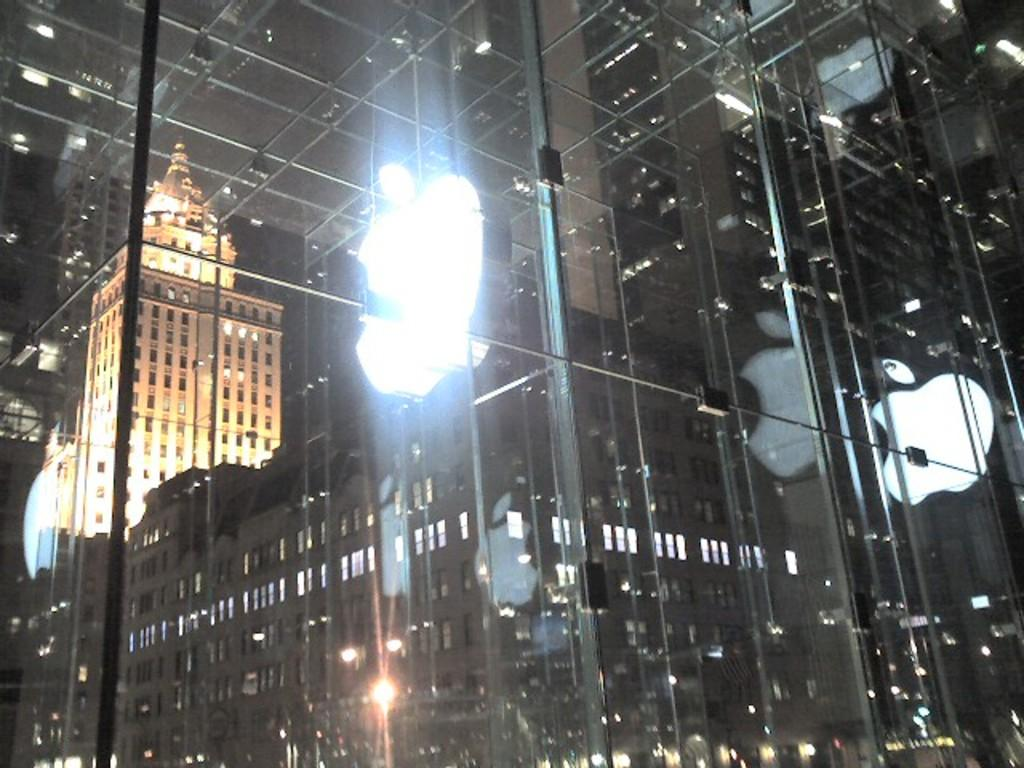What is the main feature of the image? There is a glass window in the image. What can be seen through the glass window? Buildings and towers are visible through the window. How is the image illuminated? The image has a light focus. Where is the mom in the image? There is no mom present in the image; it only features a glass window with buildings and towers visible through it. 